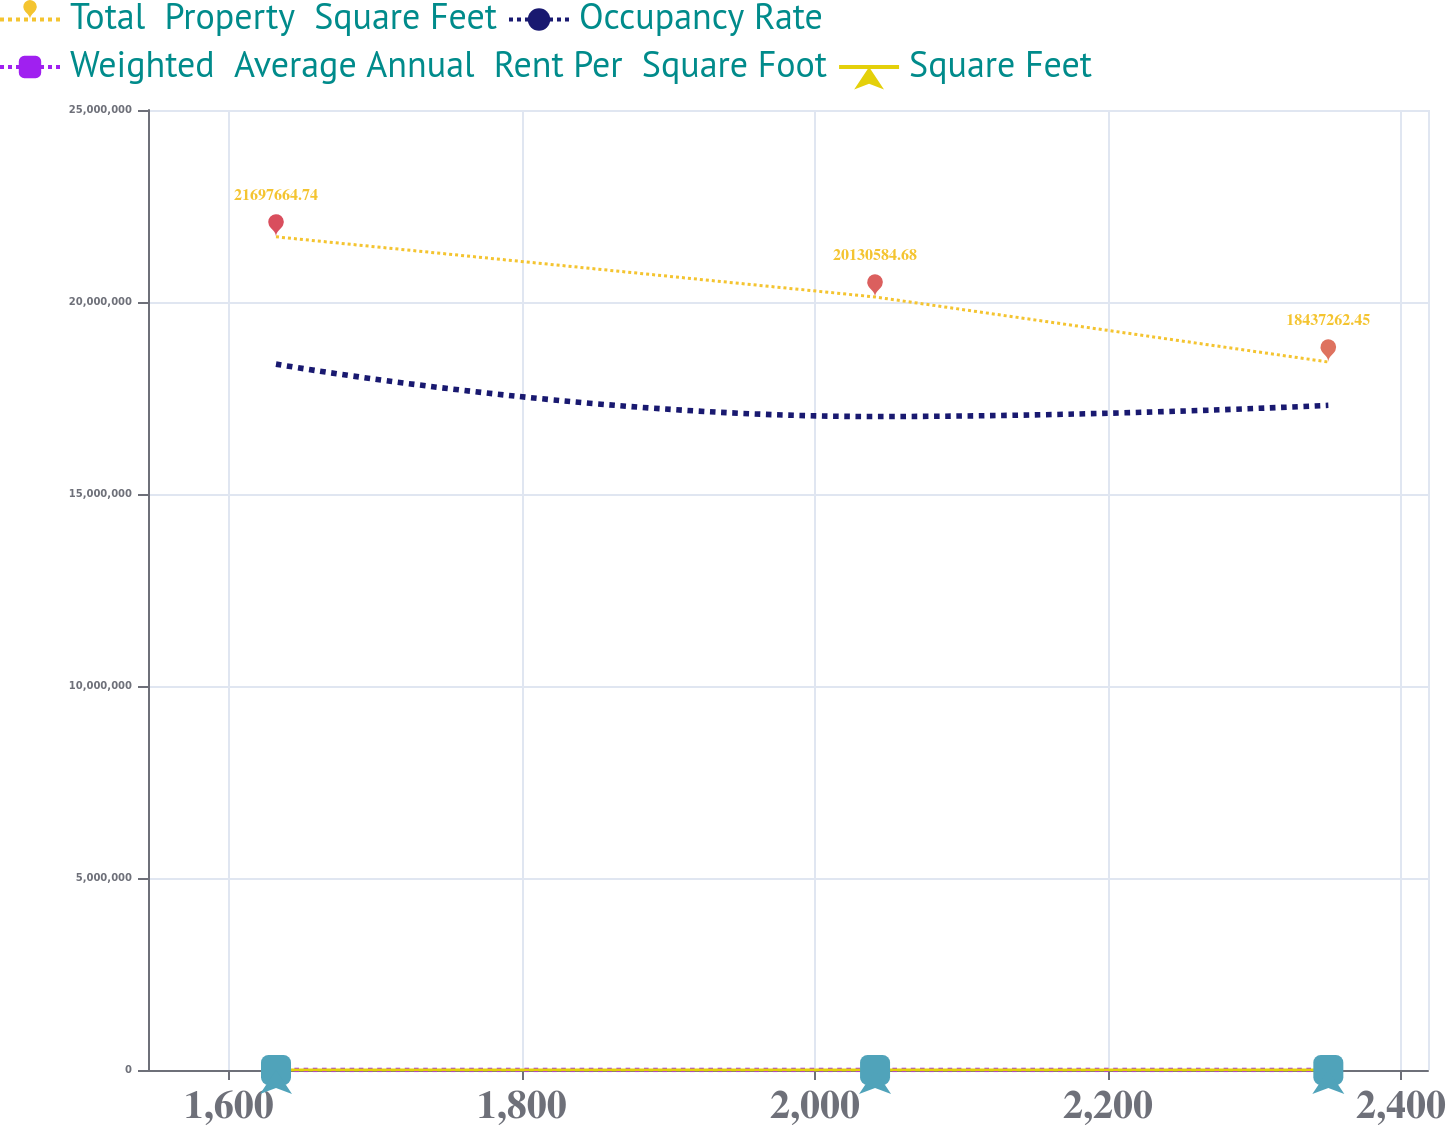Convert chart. <chart><loc_0><loc_0><loc_500><loc_500><line_chart><ecel><fcel>Total  Property  Square Feet<fcel>Occupancy Rate<fcel>Weighted  Average Annual  Rent Per  Square Foot<fcel>Square Feet<nl><fcel>1632.22<fcel>2.16977e+07<fcel>1.83823e+07<fcel>93.45<fcel>73.59<nl><fcel>2041.02<fcel>2.01306e+07<fcel>1.70177e+07<fcel>79.54<fcel>60.1<nl><fcel>2350.34<fcel>1.84373e+07<fcel>1.73093e+07<fcel>100.29<fcel>52.51<nl><fcel>2428.02<fcel>1.79089e+07<fcel>1.58394e+07<fcel>96.87<fcel>71.6<nl><fcel>2505.7<fcel>1.64143e+07<fcel>1.62726e+07<fcel>113.74<fcel>64.69<nl></chart> 